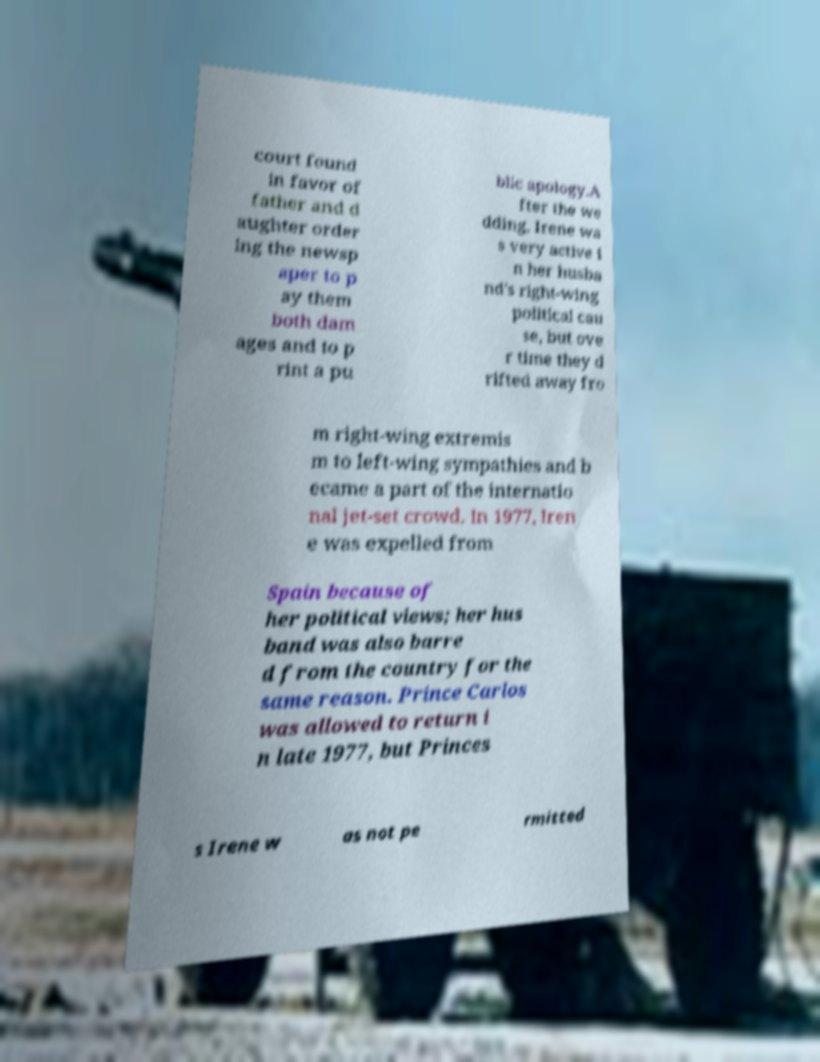For documentation purposes, I need the text within this image transcribed. Could you provide that? court found in favor of father and d aughter order ing the newsp aper to p ay them both dam ages and to p rint a pu blic apology.A fter the we dding, Irene wa s very active i n her husba nd's right-wing political cau se, but ove r time they d rifted away fro m right-wing extremis m to left-wing sympathies and b ecame a part of the internatio nal jet-set crowd. In 1977, Iren e was expelled from Spain because of her political views; her hus band was also barre d from the country for the same reason. Prince Carlos was allowed to return i n late 1977, but Princes s Irene w as not pe rmitted 